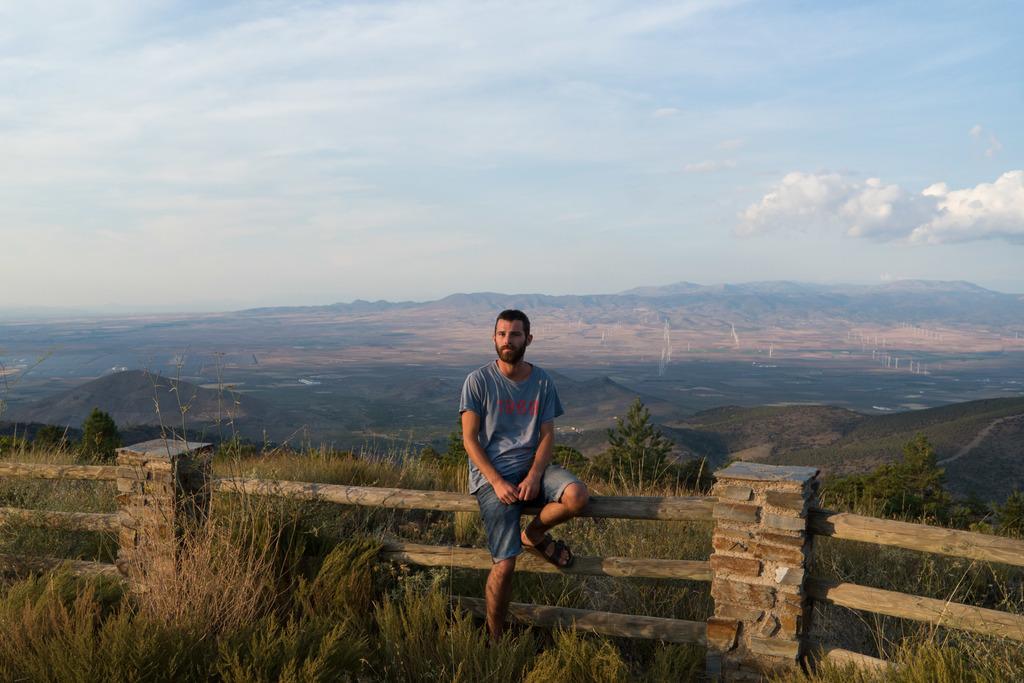Describe this image in one or two sentences. In this image there is a person sitting on the fence, and there are plants, grass, trees, hills, and in the background there is sky. 